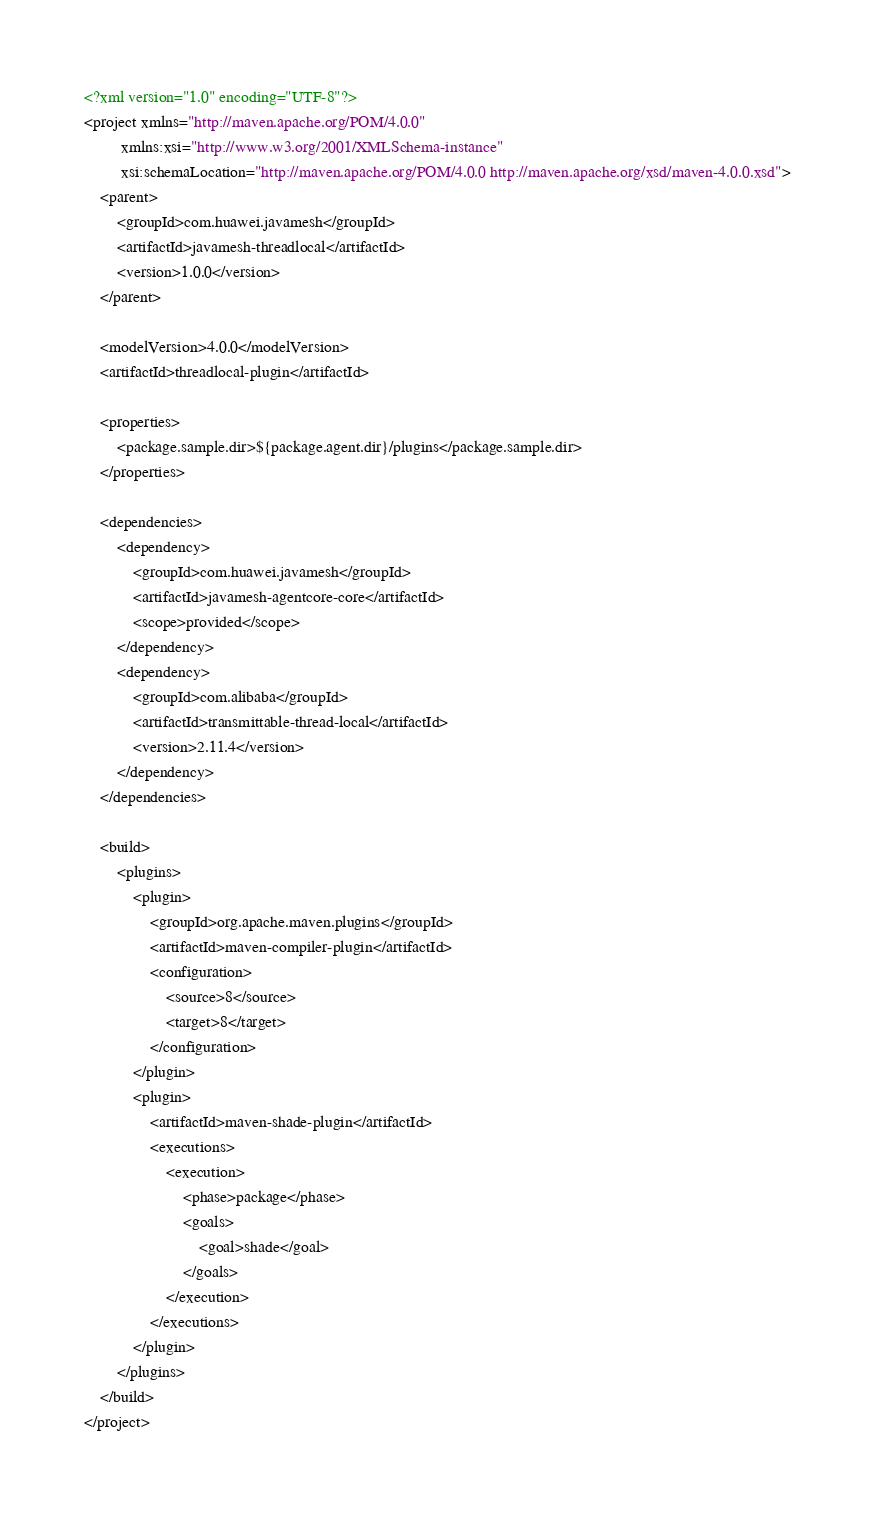<code> <loc_0><loc_0><loc_500><loc_500><_XML_><?xml version="1.0" encoding="UTF-8"?>
<project xmlns="http://maven.apache.org/POM/4.0.0"
         xmlns:xsi="http://www.w3.org/2001/XMLSchema-instance"
         xsi:schemaLocation="http://maven.apache.org/POM/4.0.0 http://maven.apache.org/xsd/maven-4.0.0.xsd">
    <parent>
        <groupId>com.huawei.javamesh</groupId>
        <artifactId>javamesh-threadlocal</artifactId>
        <version>1.0.0</version>
    </parent>

    <modelVersion>4.0.0</modelVersion>
    <artifactId>threadlocal-plugin</artifactId>

    <properties>
        <package.sample.dir>${package.agent.dir}/plugins</package.sample.dir>
    </properties>

    <dependencies>
        <dependency>
            <groupId>com.huawei.javamesh</groupId>
            <artifactId>javamesh-agentcore-core</artifactId>
            <scope>provided</scope>
        </dependency>
        <dependency>
            <groupId>com.alibaba</groupId>
            <artifactId>transmittable-thread-local</artifactId>
            <version>2.11.4</version>
        </dependency>
    </dependencies>

    <build>
        <plugins>
            <plugin>
                <groupId>org.apache.maven.plugins</groupId>
                <artifactId>maven-compiler-plugin</artifactId>
                <configuration>
                    <source>8</source>
                    <target>8</target>
                </configuration>
            </plugin>
            <plugin>
                <artifactId>maven-shade-plugin</artifactId>
                <executions>
                    <execution>
                        <phase>package</phase>
                        <goals>
                            <goal>shade</goal>
                        </goals>
                    </execution>
                </executions>
            </plugin>
        </plugins>
    </build>
</project></code> 